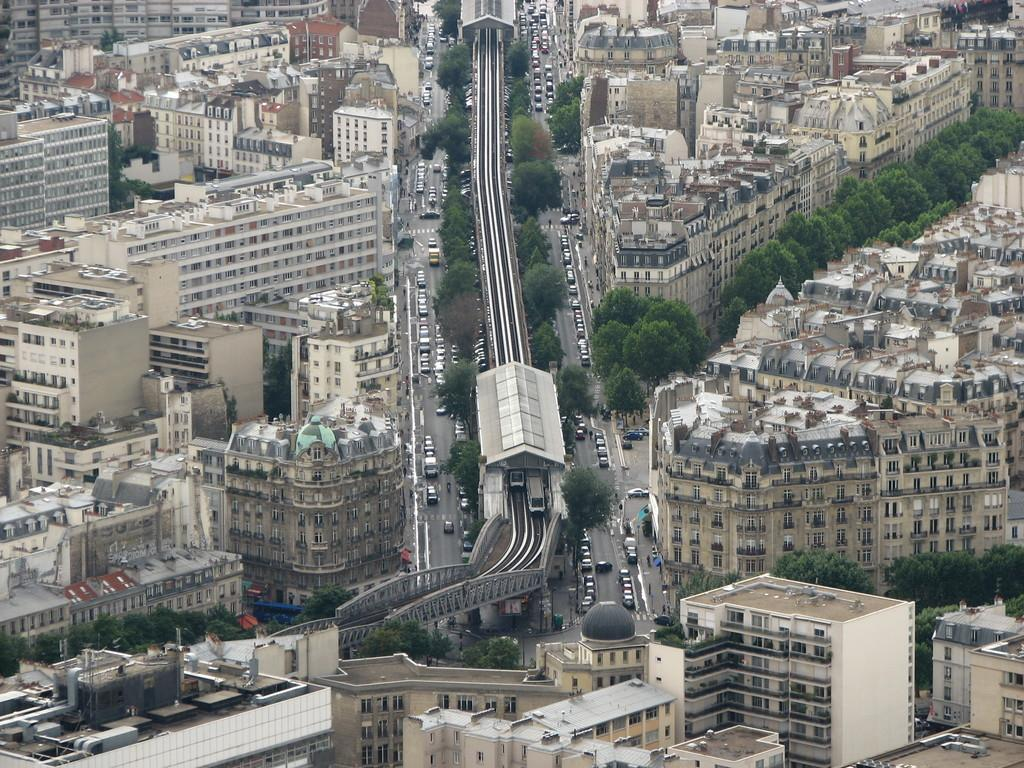What type of structures can be seen in the image? There are buildings in the image. What other natural elements are present in the image? There are trees in the image. What is happening on the road in the image? There are vehicles moving on the road in the image. Are there any transportation-related features in the image? Yes, there appear to be rail tracks in the image. Can you tell me how many boats are docked near the garden in the image? There is no boat or garden present in the image. How does the increase in traffic affect the garden in the image? There is no garden present in the image, so it is not possible to determine the effect of traffic on it. 